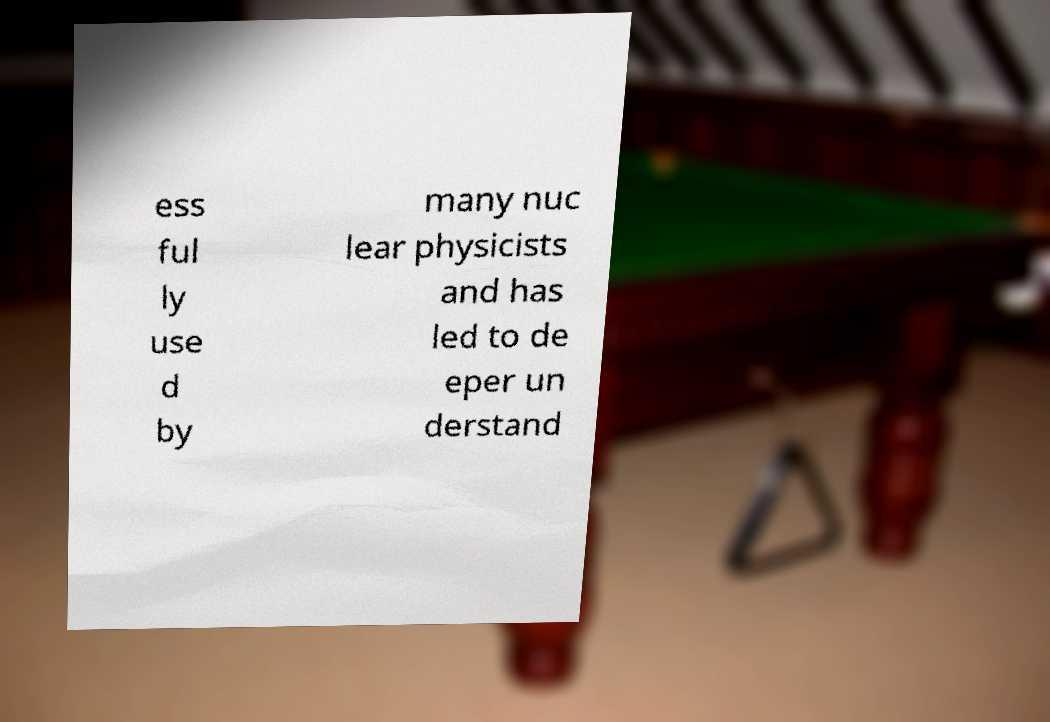Could you extract and type out the text from this image? ess ful ly use d by many nuc lear physicists and has led to de eper un derstand 